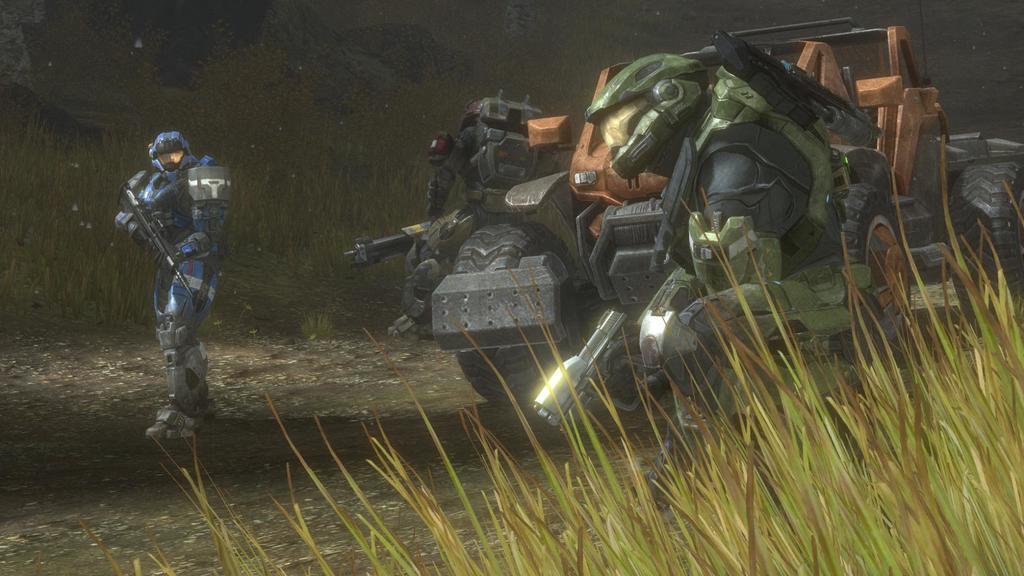What type of picture is in the image? The image contains an animated picture. What can be seen moving in the image? There is a vehicle in the image. How many robots are present in the image? There are 3 robots in the image. What type of terrain is visible in the image? There is grass visible in the image. What color is the background of the image? The background of the image is black. What scientific discovery is being made by the robots in the image? There is no indication in the image that the robots are making any scientific discoveries. 